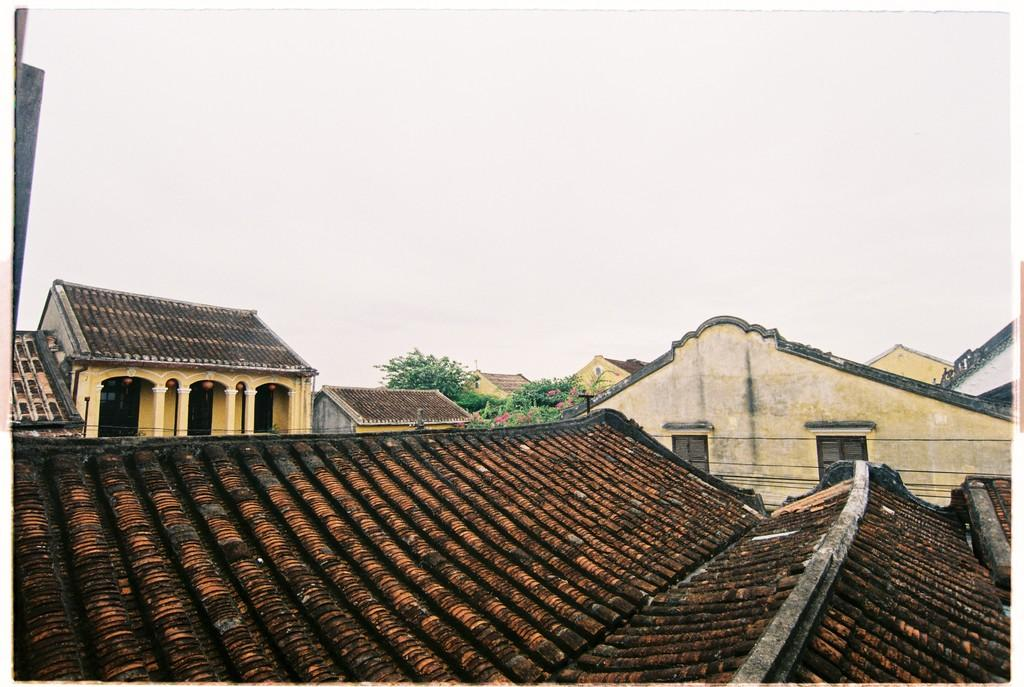What type of structures can be seen in the image? There are houses in the image. What color are the roofs of the houses? The roofs of the houses are brown and maroon in color. What feature of the houses allows light and air to enter? There are windows in the houses. What type of impulse can be seen affecting the base of the houses in the image? There is no impulse or base present in the image; it features houses with roofs and windows. What type of pump is visible in the image? There is no pump present in the image. 